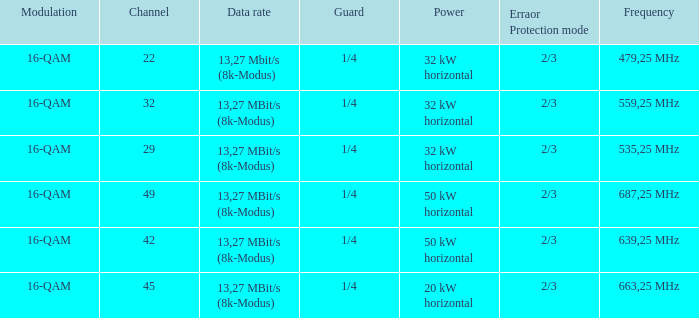On channel 32, when the power is 32 kw horizontally, what is the frequency? 559,25 MHz. 